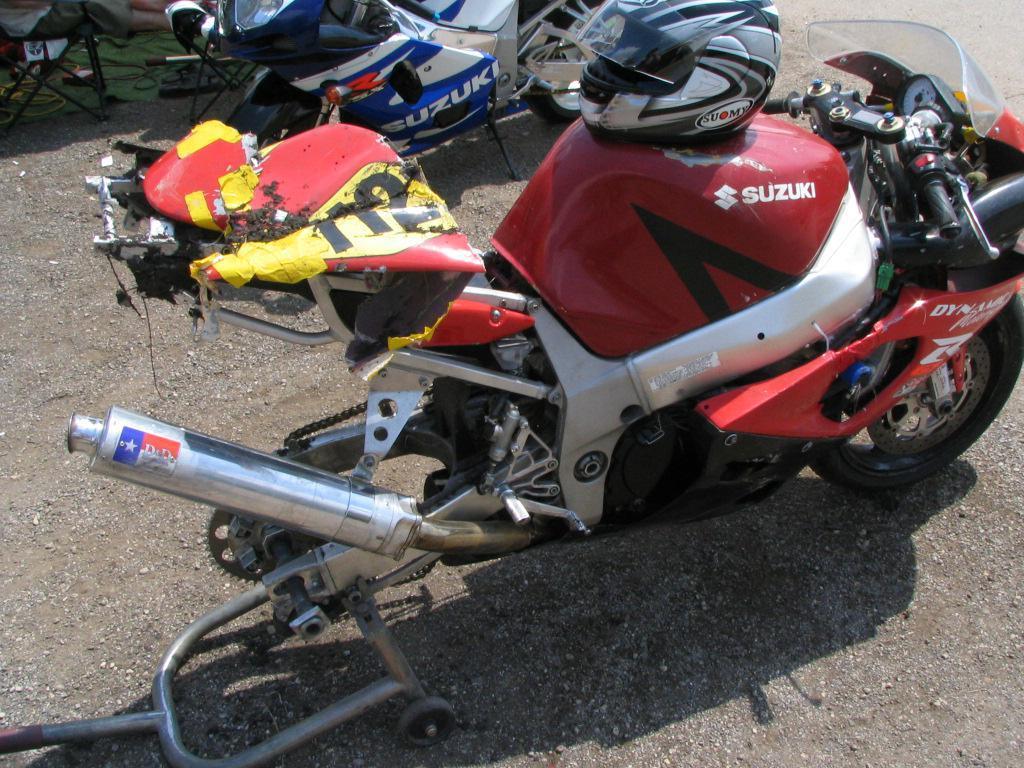In one or two sentences, can you explain what this image depicts? In this picture we can see motorbikes on the road, helmet and in the background we can see chairs. 